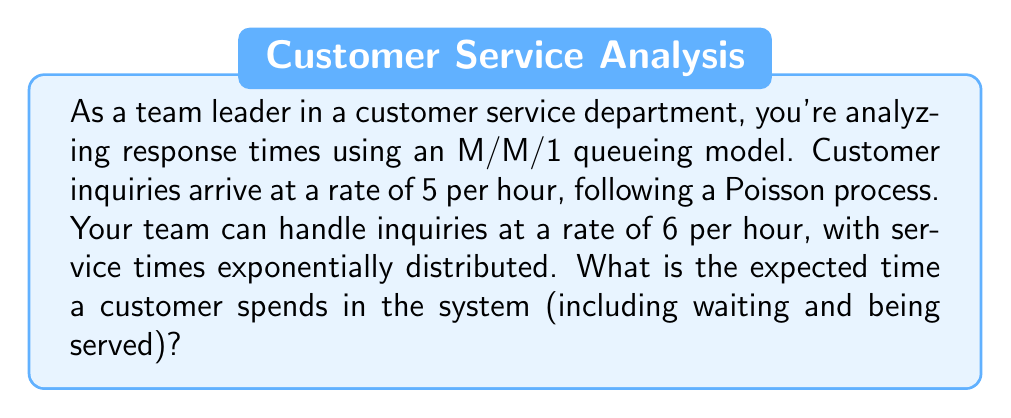Help me with this question. To solve this problem, we'll use the M/M/1 queueing model and follow these steps:

1. Identify the given parameters:
   $\lambda$ = arrival rate = 5 per hour
   $\mu$ = service rate = 6 per hour

2. Calculate the utilization factor $\rho$:
   $$\rho = \frac{\lambda}{\mu} = \frac{5}{6} \approx 0.8333$$

3. Use the formula for expected time in the system (W) for an M/M/1 queue:
   $$W = \frac{1}{\mu - \lambda}$$

4. Substitute the values:
   $$W = \frac{1}{6 - 5} = \frac{1}{1} = 1$$

5. Interpret the result:
   The expected time a customer spends in the system is 1 hour.

This analysis helps you understand the current performance of your team and can be used to set realistic expectations for response times or identify areas for improvement.
Answer: 1 hour 